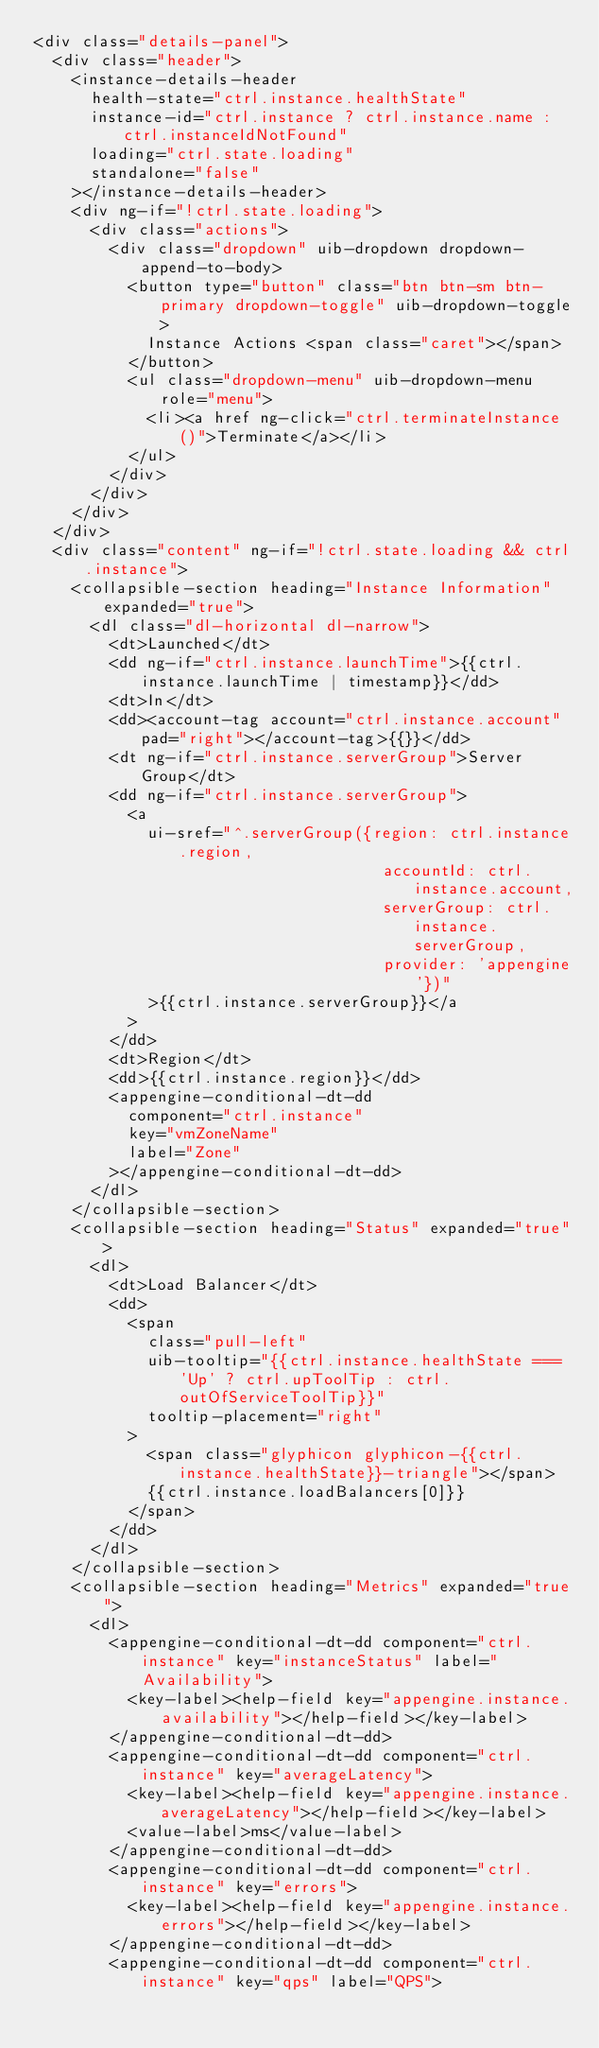Convert code to text. <code><loc_0><loc_0><loc_500><loc_500><_HTML_><div class="details-panel">
  <div class="header">
    <instance-details-header
      health-state="ctrl.instance.healthState"
      instance-id="ctrl.instance ? ctrl.instance.name : ctrl.instanceIdNotFound"
      loading="ctrl.state.loading"
      standalone="false"
    ></instance-details-header>
    <div ng-if="!ctrl.state.loading">
      <div class="actions">
        <div class="dropdown" uib-dropdown dropdown-append-to-body>
          <button type="button" class="btn btn-sm btn-primary dropdown-toggle" uib-dropdown-toggle>
            Instance Actions <span class="caret"></span>
          </button>
          <ul class="dropdown-menu" uib-dropdown-menu role="menu">
            <li><a href ng-click="ctrl.terminateInstance()">Terminate</a></li>
          </ul>
        </div>
      </div>
    </div>
  </div>
  <div class="content" ng-if="!ctrl.state.loading && ctrl.instance">
    <collapsible-section heading="Instance Information" expanded="true">
      <dl class="dl-horizontal dl-narrow">
        <dt>Launched</dt>
        <dd ng-if="ctrl.instance.launchTime">{{ctrl.instance.launchTime | timestamp}}</dd>
        <dt>In</dt>
        <dd><account-tag account="ctrl.instance.account" pad="right"></account-tag>{{}}</dd>
        <dt ng-if="ctrl.instance.serverGroup">Server Group</dt>
        <dd ng-if="ctrl.instance.serverGroup">
          <a
            ui-sref="^.serverGroup({region: ctrl.instance.region,
                                     accountId: ctrl.instance.account,
                                     serverGroup: ctrl.instance.serverGroup,
                                     provider: 'appengine'})"
            >{{ctrl.instance.serverGroup}}</a
          >
        </dd>
        <dt>Region</dt>
        <dd>{{ctrl.instance.region}}</dd>
        <appengine-conditional-dt-dd
          component="ctrl.instance"
          key="vmZoneName"
          label="Zone"
        ></appengine-conditional-dt-dd>
      </dl>
    </collapsible-section>
    <collapsible-section heading="Status" expanded="true">
      <dl>
        <dt>Load Balancer</dt>
        <dd>
          <span
            class="pull-left"
            uib-tooltip="{{ctrl.instance.healthState === 'Up' ? ctrl.upToolTip : ctrl.outOfServiceToolTip}}"
            tooltip-placement="right"
          >
            <span class="glyphicon glyphicon-{{ctrl.instance.healthState}}-triangle"></span>
            {{ctrl.instance.loadBalancers[0]}}
          </span>
        </dd>
      </dl>
    </collapsible-section>
    <collapsible-section heading="Metrics" expanded="true">
      <dl>
        <appengine-conditional-dt-dd component="ctrl.instance" key="instanceStatus" label="Availability">
          <key-label><help-field key="appengine.instance.availability"></help-field></key-label>
        </appengine-conditional-dt-dd>
        <appengine-conditional-dt-dd component="ctrl.instance" key="averageLatency">
          <key-label><help-field key="appengine.instance.averageLatency"></help-field></key-label>
          <value-label>ms</value-label>
        </appengine-conditional-dt-dd>
        <appengine-conditional-dt-dd component="ctrl.instance" key="errors">
          <key-label><help-field key="appengine.instance.errors"></help-field></key-label>
        </appengine-conditional-dt-dd>
        <appengine-conditional-dt-dd component="ctrl.instance" key="qps" label="QPS"></code> 